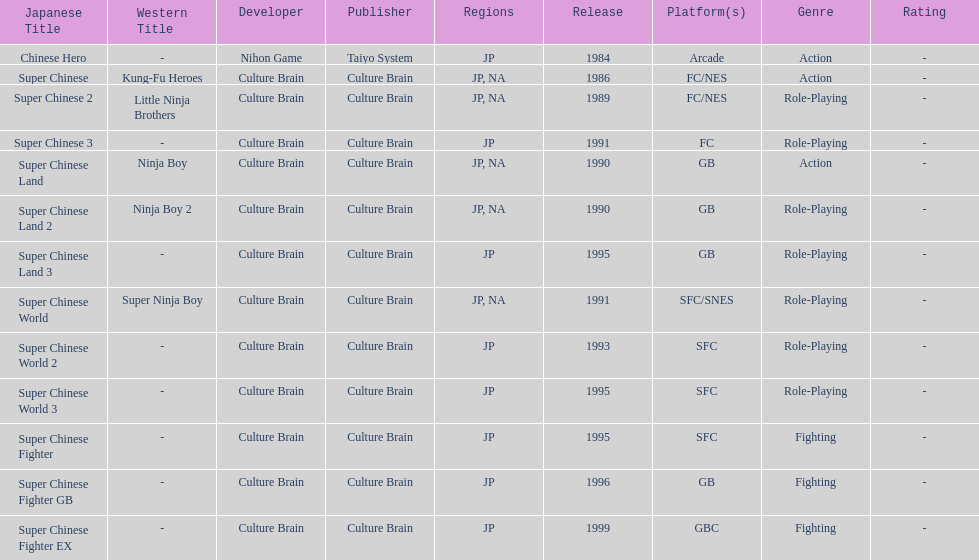How many action games were released in north america? 2. 